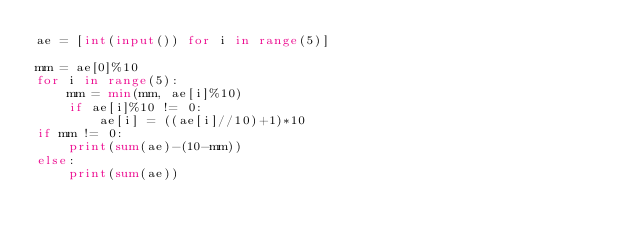<code> <loc_0><loc_0><loc_500><loc_500><_Python_>ae = [int(input()) for i in range(5)]

mm = ae[0]%10
for i in range(5):
    mm = min(mm, ae[i]%10)
    if ae[i]%10 != 0:
        ae[i] = ((ae[i]//10)+1)*10
if mm != 0:
    print(sum(ae)-(10-mm))
else:
    print(sum(ae))</code> 